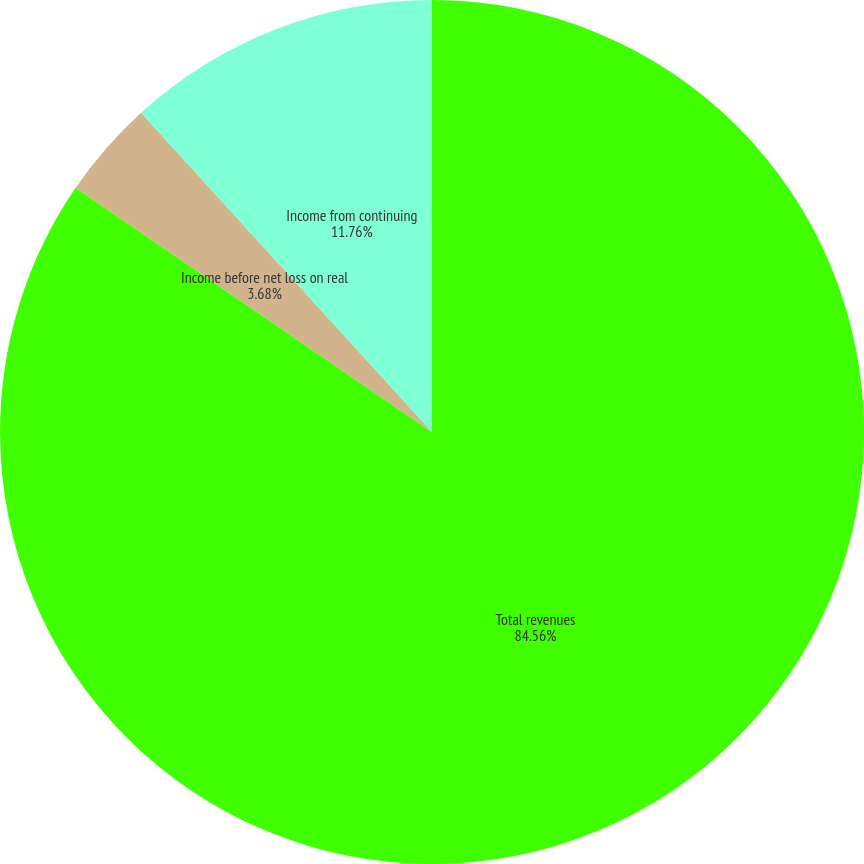Convert chart to OTSL. <chart><loc_0><loc_0><loc_500><loc_500><pie_chart><fcel>Total revenues<fcel>Income before net loss on real<fcel>Income from continuing<nl><fcel>84.56%<fcel>3.68%<fcel>11.76%<nl></chart> 